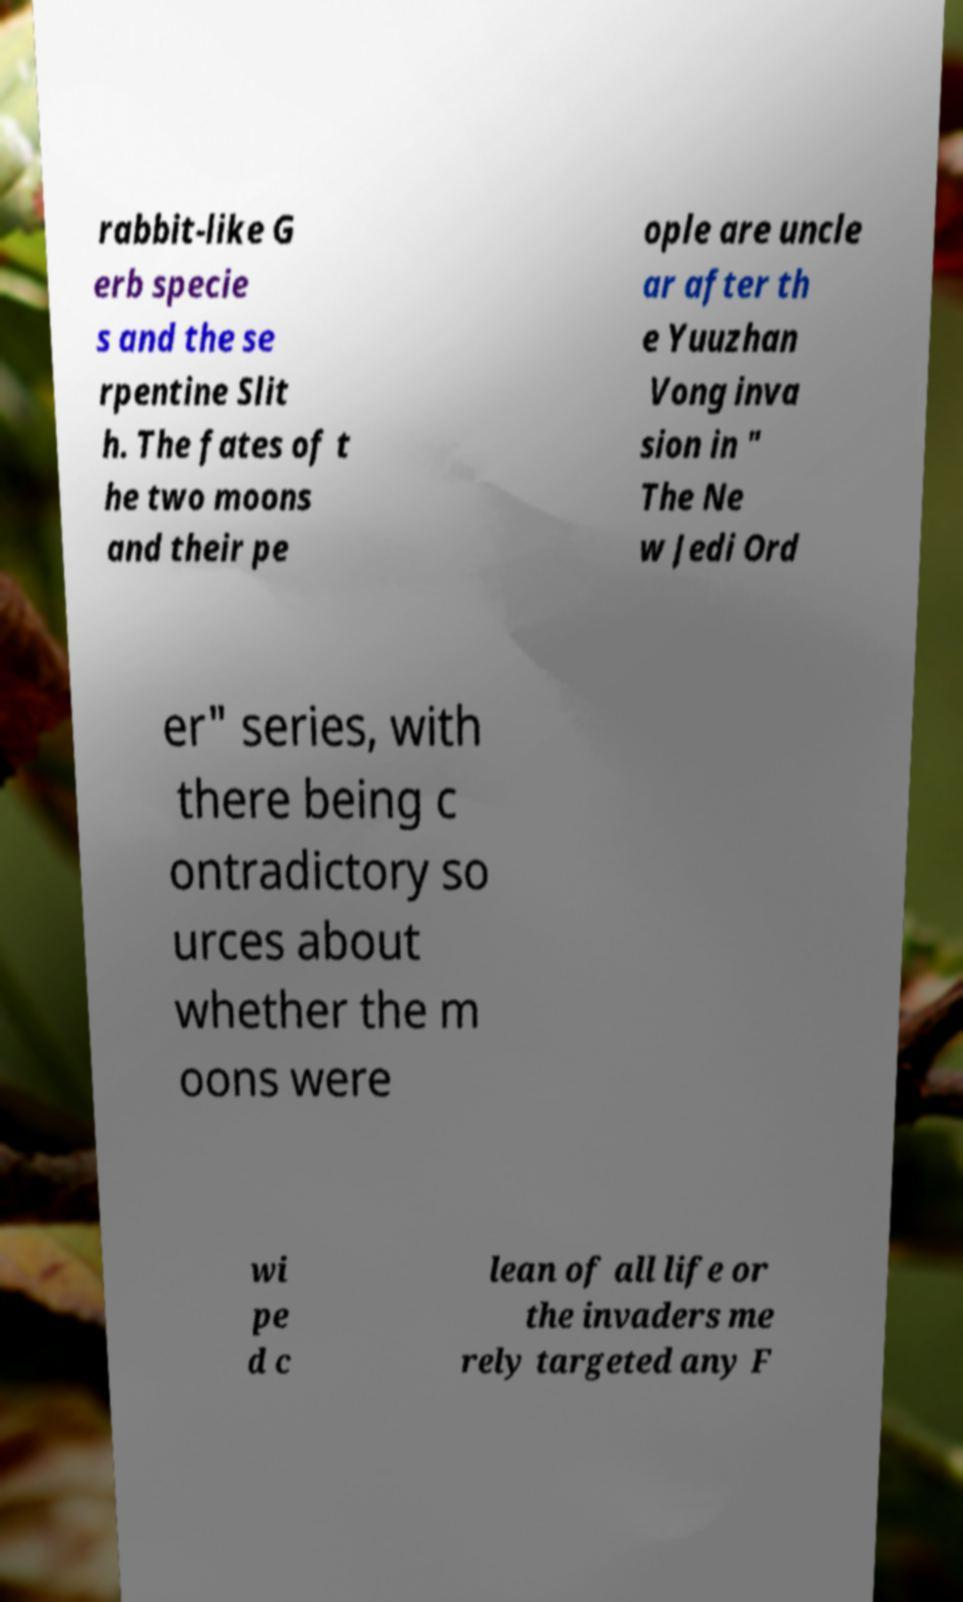There's text embedded in this image that I need extracted. Can you transcribe it verbatim? rabbit-like G erb specie s and the se rpentine Slit h. The fates of t he two moons and their pe ople are uncle ar after th e Yuuzhan Vong inva sion in " The Ne w Jedi Ord er" series, with there being c ontradictory so urces about whether the m oons were wi pe d c lean of all life or the invaders me rely targeted any F 